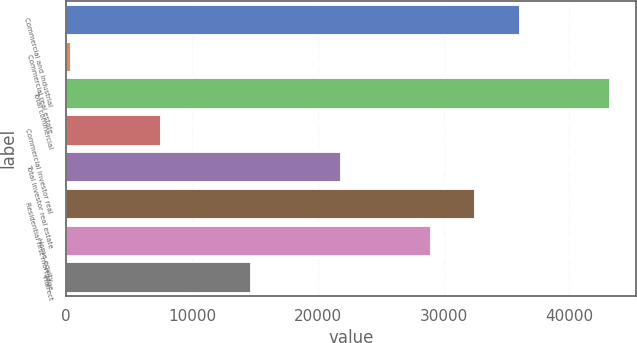Convert chart. <chart><loc_0><loc_0><loc_500><loc_500><bar_chart><fcel>Commercial and industrial<fcel>Commercial real estate<fcel>Total commercial<fcel>Commercial investor real<fcel>Total investor real estate<fcel>Residential first mortgage<fcel>Home equity<fcel>Indirect<nl><fcel>36025<fcel>337<fcel>43162.6<fcel>7474.6<fcel>21749.8<fcel>32456.2<fcel>28887.4<fcel>14612.2<nl></chart> 